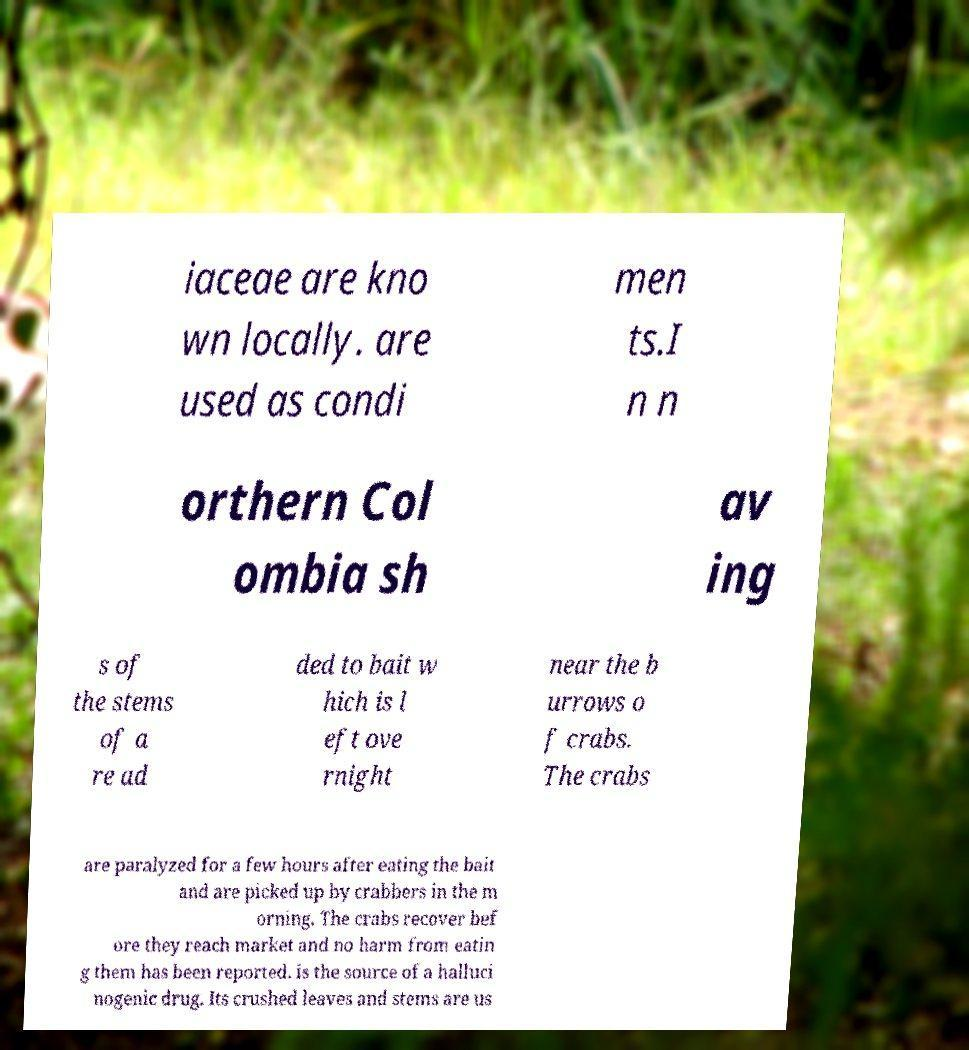Could you extract and type out the text from this image? iaceae are kno wn locally. are used as condi men ts.I n n orthern Col ombia sh av ing s of the stems of a re ad ded to bait w hich is l eft ove rnight near the b urrows o f crabs. The crabs are paralyzed for a few hours after eating the bait and are picked up by crabbers in the m orning. The crabs recover bef ore they reach market and no harm from eatin g them has been reported. is the source of a halluci nogenic drug. Its crushed leaves and stems are us 